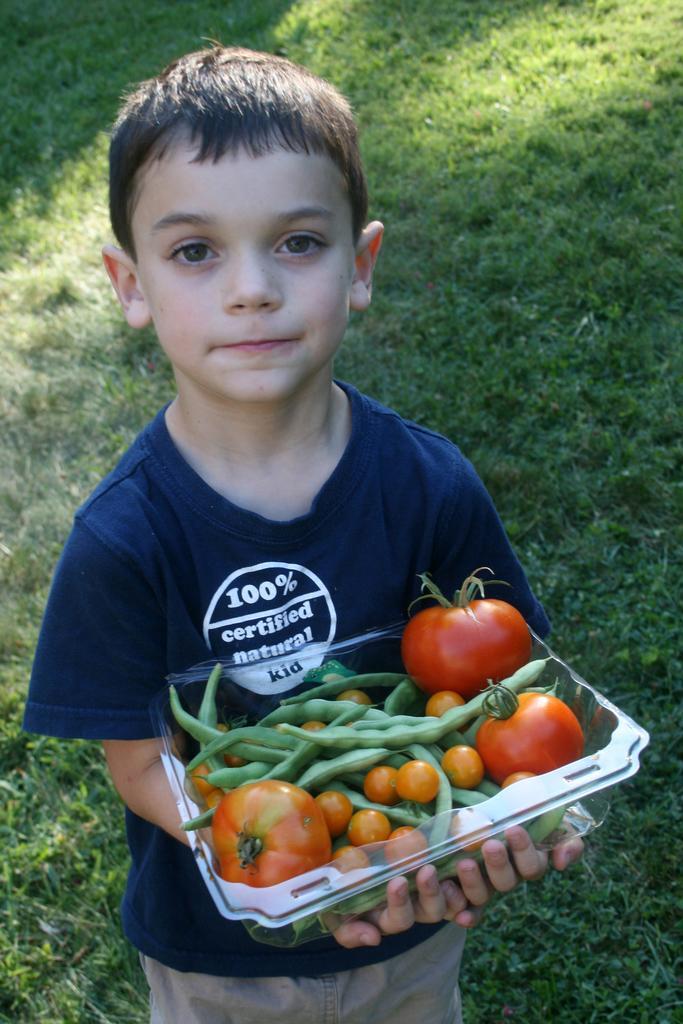How would you summarize this image in a sentence or two? In this picture there is a boy standing and holding the box and there are vegetables in the box. At the bottom there is grass. 